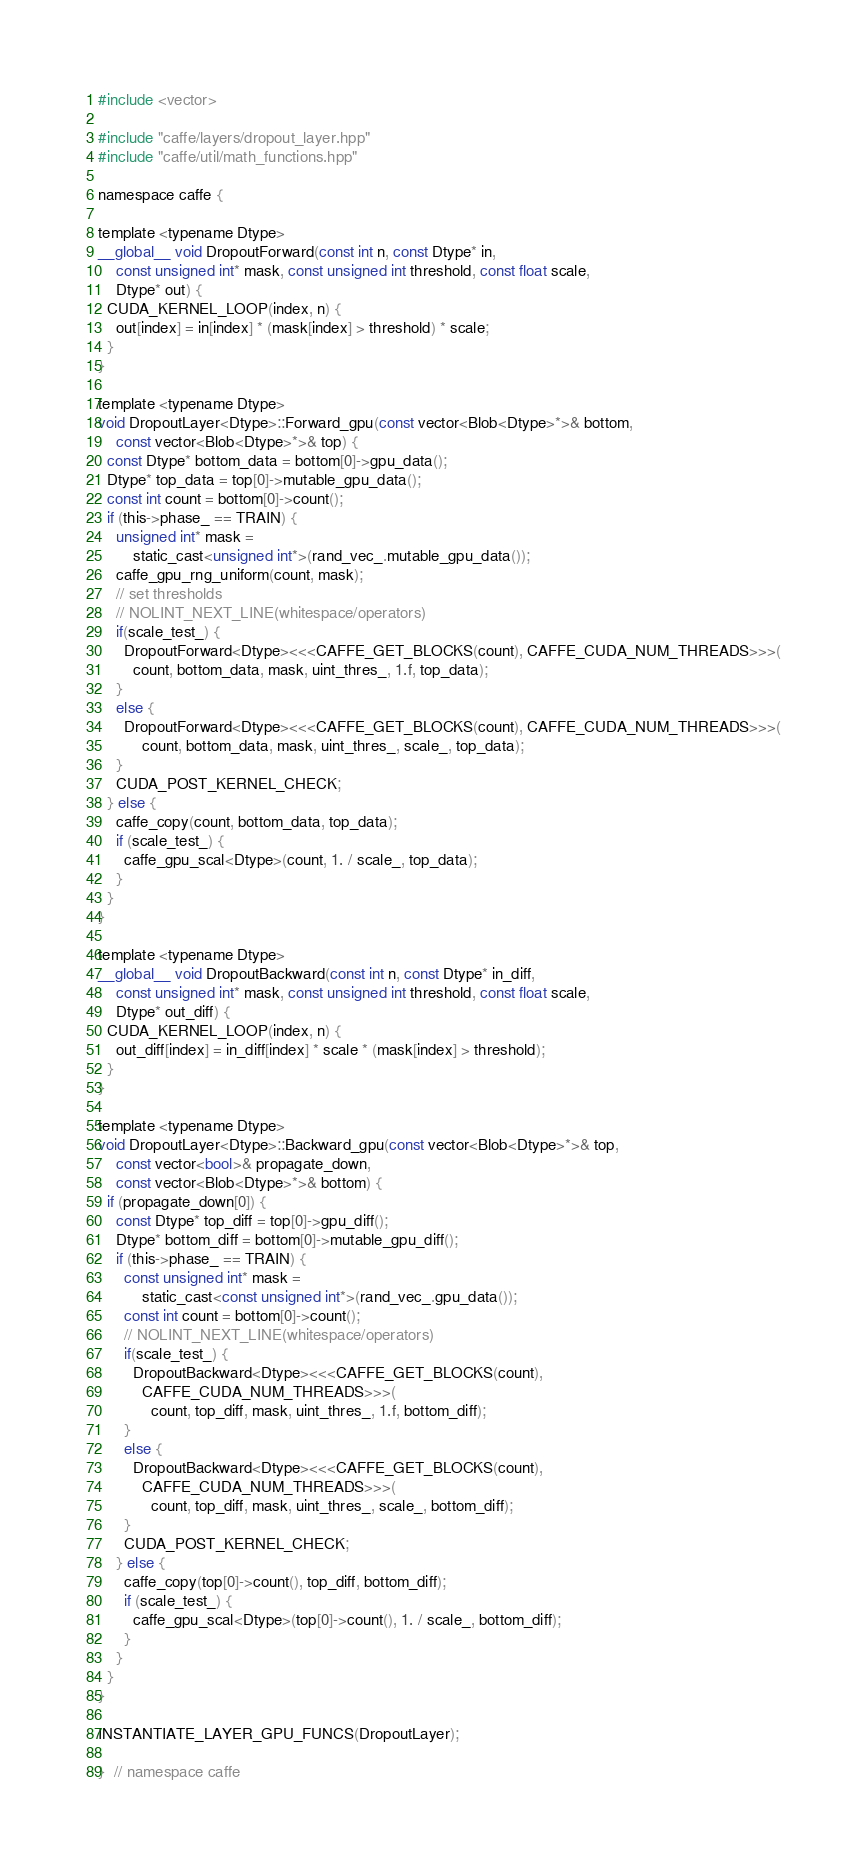<code> <loc_0><loc_0><loc_500><loc_500><_Cuda_>#include <vector>

#include "caffe/layers/dropout_layer.hpp"
#include "caffe/util/math_functions.hpp"

namespace caffe {

template <typename Dtype>
__global__ void DropoutForward(const int n, const Dtype* in,
    const unsigned int* mask, const unsigned int threshold, const float scale,
    Dtype* out) {
  CUDA_KERNEL_LOOP(index, n) {
    out[index] = in[index] * (mask[index] > threshold) * scale;
  }
}

template <typename Dtype>
void DropoutLayer<Dtype>::Forward_gpu(const vector<Blob<Dtype>*>& bottom,
    const vector<Blob<Dtype>*>& top) {
  const Dtype* bottom_data = bottom[0]->gpu_data();
  Dtype* top_data = top[0]->mutable_gpu_data();
  const int count = bottom[0]->count();
  if (this->phase_ == TRAIN) {
    unsigned int* mask =
        static_cast<unsigned int*>(rand_vec_.mutable_gpu_data());
    caffe_gpu_rng_uniform(count, mask);
    // set thresholds
    // NOLINT_NEXT_LINE(whitespace/operators)
    if(scale_test_) {
      DropoutForward<Dtype><<<CAFFE_GET_BLOCKS(count), CAFFE_CUDA_NUM_THREADS>>>(
        count, bottom_data, mask, uint_thres_, 1.f, top_data);
    }
    else {
      DropoutForward<Dtype><<<CAFFE_GET_BLOCKS(count), CAFFE_CUDA_NUM_THREADS>>>(
          count, bottom_data, mask, uint_thres_, scale_, top_data);
    }
    CUDA_POST_KERNEL_CHECK;
  } else {
    caffe_copy(count, bottom_data, top_data);
    if (scale_test_) {
      caffe_gpu_scal<Dtype>(count, 1. / scale_, top_data);
    }
  }
}

template <typename Dtype>
__global__ void DropoutBackward(const int n, const Dtype* in_diff,
    const unsigned int* mask, const unsigned int threshold, const float scale,
    Dtype* out_diff) {
  CUDA_KERNEL_LOOP(index, n) {
    out_diff[index] = in_diff[index] * scale * (mask[index] > threshold);
  }
}

template <typename Dtype>
void DropoutLayer<Dtype>::Backward_gpu(const vector<Blob<Dtype>*>& top,
    const vector<bool>& propagate_down,
    const vector<Blob<Dtype>*>& bottom) {
  if (propagate_down[0]) {
    const Dtype* top_diff = top[0]->gpu_diff();
    Dtype* bottom_diff = bottom[0]->mutable_gpu_diff();
    if (this->phase_ == TRAIN) {
      const unsigned int* mask =
          static_cast<const unsigned int*>(rand_vec_.gpu_data());
      const int count = bottom[0]->count();
      // NOLINT_NEXT_LINE(whitespace/operators)
      if(scale_test_) {
        DropoutBackward<Dtype><<<CAFFE_GET_BLOCKS(count),
          CAFFE_CUDA_NUM_THREADS>>>(
            count, top_diff, mask, uint_thres_, 1.f, bottom_diff);
      }
      else {
        DropoutBackward<Dtype><<<CAFFE_GET_BLOCKS(count),
          CAFFE_CUDA_NUM_THREADS>>>(
            count, top_diff, mask, uint_thres_, scale_, bottom_diff);
      }
      CUDA_POST_KERNEL_CHECK;
    } else {
      caffe_copy(top[0]->count(), top_diff, bottom_diff);
      if (scale_test_) {
        caffe_gpu_scal<Dtype>(top[0]->count(), 1. / scale_, bottom_diff);
      }
    }
  }
}

INSTANTIATE_LAYER_GPU_FUNCS(DropoutLayer);

}  // namespace caffe
</code> 